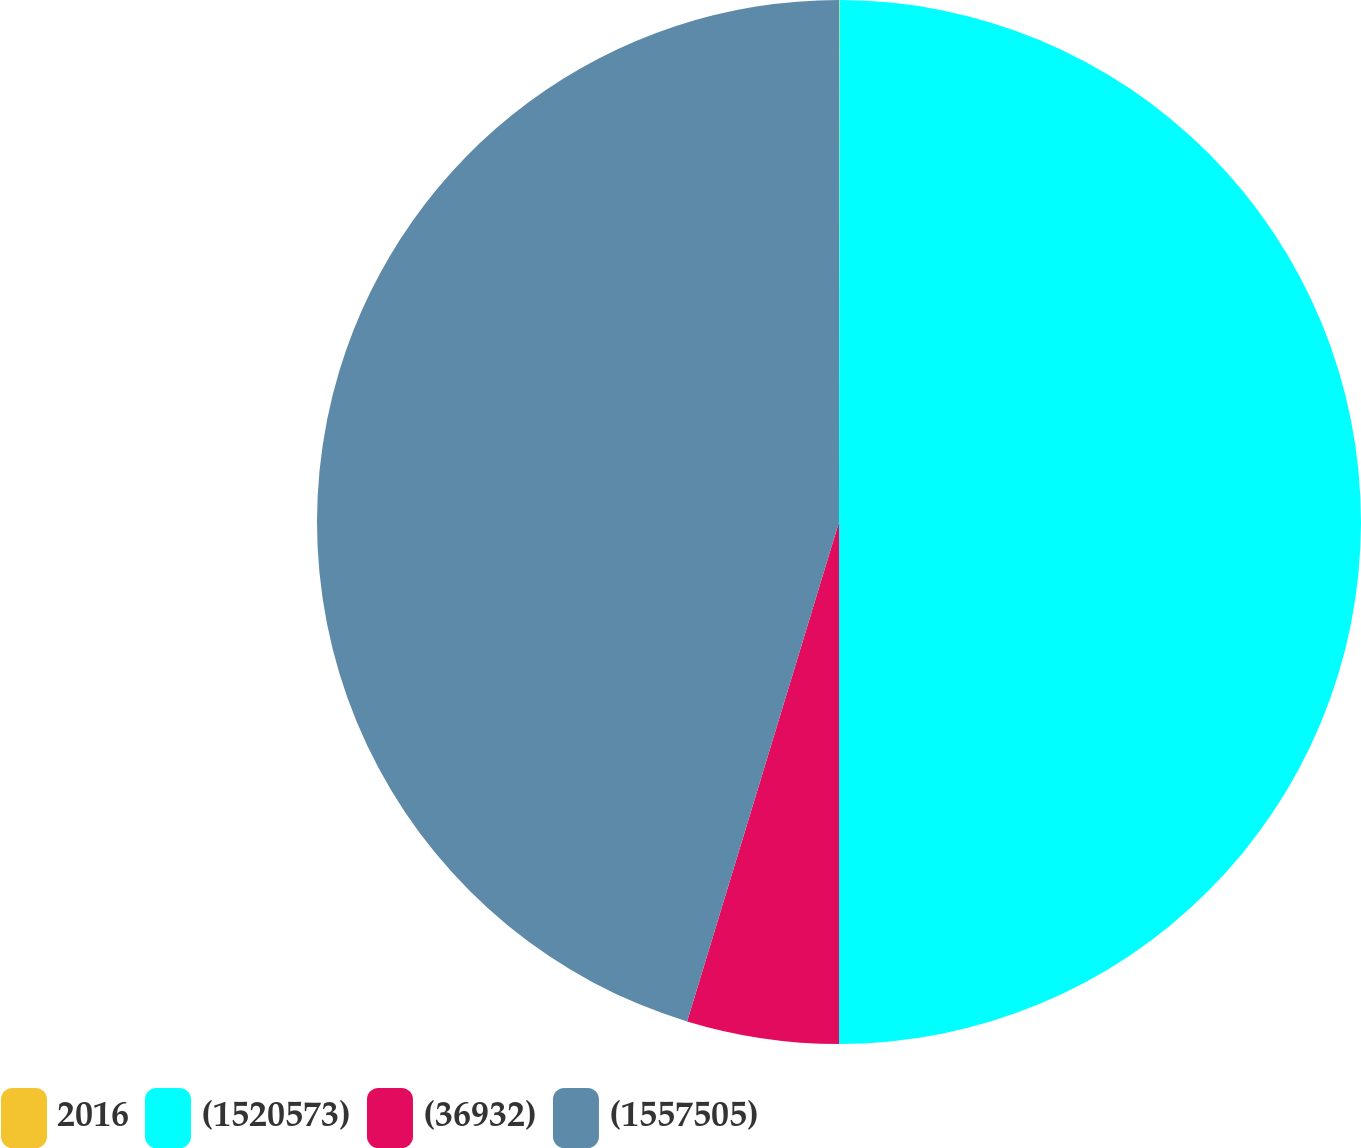Convert chart. <chart><loc_0><loc_0><loc_500><loc_500><pie_chart><fcel>2016<fcel>(1520573)<fcel>(36932)<fcel>(1557505)<nl><fcel>0.02%<fcel>49.98%<fcel>4.7%<fcel>45.3%<nl></chart> 